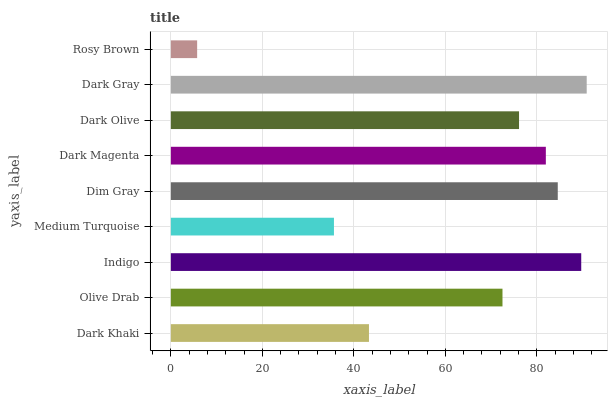Is Rosy Brown the minimum?
Answer yes or no. Yes. Is Dark Gray the maximum?
Answer yes or no. Yes. Is Olive Drab the minimum?
Answer yes or no. No. Is Olive Drab the maximum?
Answer yes or no. No. Is Olive Drab greater than Dark Khaki?
Answer yes or no. Yes. Is Dark Khaki less than Olive Drab?
Answer yes or no. Yes. Is Dark Khaki greater than Olive Drab?
Answer yes or no. No. Is Olive Drab less than Dark Khaki?
Answer yes or no. No. Is Dark Olive the high median?
Answer yes or no. Yes. Is Dark Olive the low median?
Answer yes or no. Yes. Is Dark Magenta the high median?
Answer yes or no. No. Is Dark Magenta the low median?
Answer yes or no. No. 